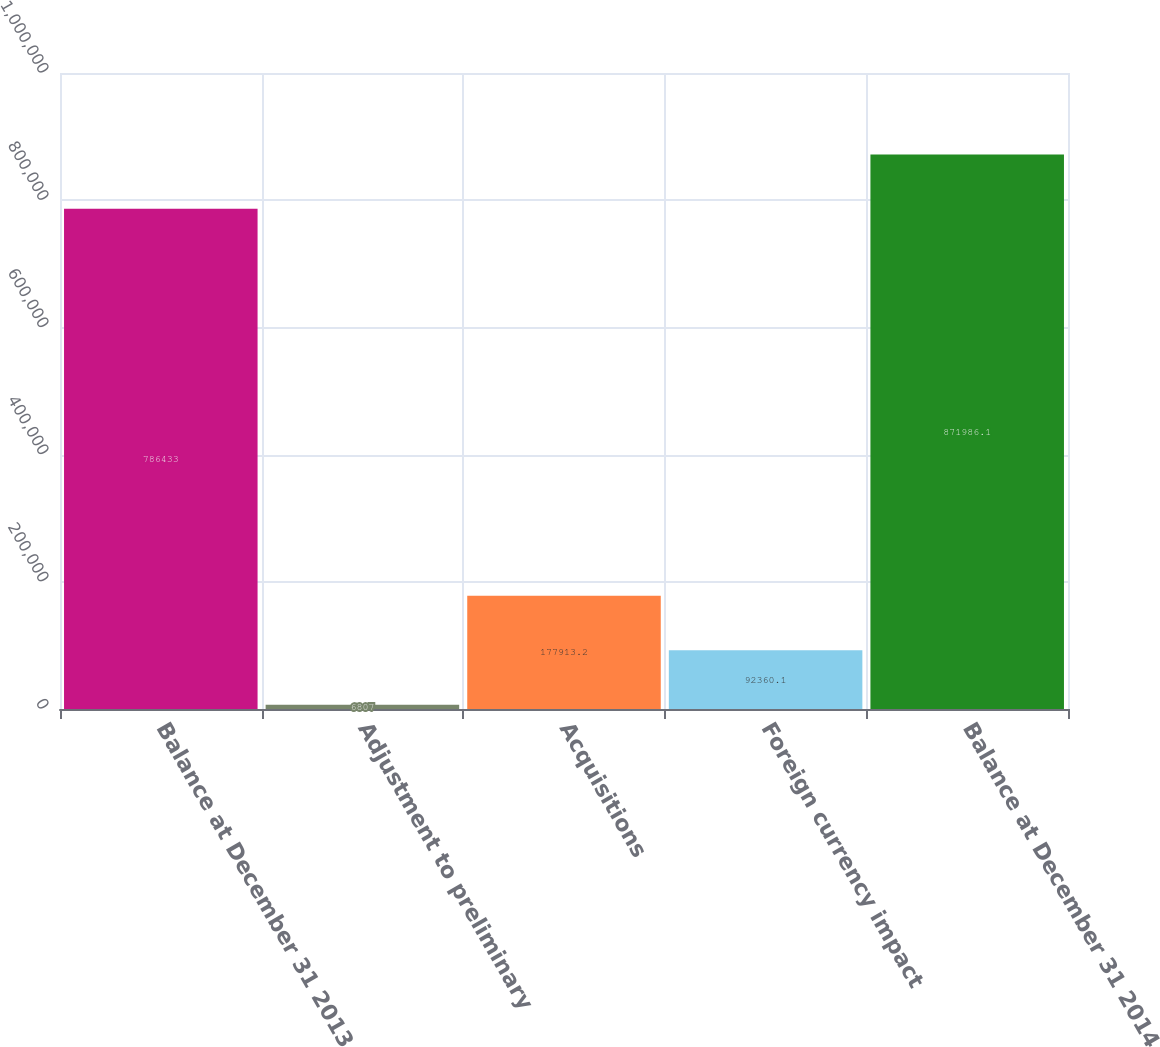Convert chart. <chart><loc_0><loc_0><loc_500><loc_500><bar_chart><fcel>Balance at December 31 2013<fcel>Adjustment to preliminary<fcel>Acquisitions<fcel>Foreign currency impact<fcel>Balance at December 31 2014<nl><fcel>786433<fcel>6807<fcel>177913<fcel>92360.1<fcel>871986<nl></chart> 